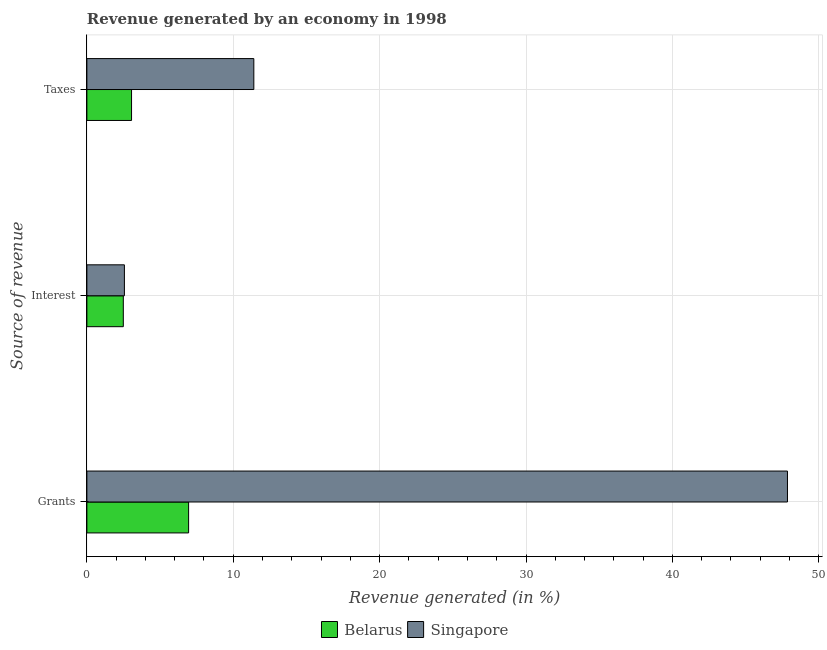How many groups of bars are there?
Keep it short and to the point. 3. Are the number of bars per tick equal to the number of legend labels?
Your answer should be very brief. Yes. How many bars are there on the 3rd tick from the bottom?
Your answer should be compact. 2. What is the label of the 1st group of bars from the top?
Offer a terse response. Taxes. What is the percentage of revenue generated by taxes in Singapore?
Your response must be concise. 11.41. Across all countries, what is the maximum percentage of revenue generated by interest?
Make the answer very short. 2.56. Across all countries, what is the minimum percentage of revenue generated by interest?
Give a very brief answer. 2.49. In which country was the percentage of revenue generated by taxes maximum?
Keep it short and to the point. Singapore. In which country was the percentage of revenue generated by interest minimum?
Your answer should be compact. Belarus. What is the total percentage of revenue generated by grants in the graph?
Provide a succinct answer. 54.81. What is the difference between the percentage of revenue generated by taxes in Belarus and that in Singapore?
Provide a succinct answer. -8.35. What is the difference between the percentage of revenue generated by interest in Singapore and the percentage of revenue generated by grants in Belarus?
Offer a very short reply. -4.39. What is the average percentage of revenue generated by grants per country?
Make the answer very short. 27.41. What is the difference between the percentage of revenue generated by taxes and percentage of revenue generated by grants in Belarus?
Offer a very short reply. -3.9. What is the ratio of the percentage of revenue generated by grants in Singapore to that in Belarus?
Ensure brevity in your answer.  6.89. Is the difference between the percentage of revenue generated by grants in Belarus and Singapore greater than the difference between the percentage of revenue generated by interest in Belarus and Singapore?
Provide a short and direct response. No. What is the difference between the highest and the second highest percentage of revenue generated by interest?
Offer a very short reply. 0.08. What is the difference between the highest and the lowest percentage of revenue generated by interest?
Keep it short and to the point. 0.08. In how many countries, is the percentage of revenue generated by interest greater than the average percentage of revenue generated by interest taken over all countries?
Provide a short and direct response. 1. Is the sum of the percentage of revenue generated by grants in Belarus and Singapore greater than the maximum percentage of revenue generated by interest across all countries?
Your answer should be very brief. Yes. What does the 1st bar from the top in Grants represents?
Keep it short and to the point. Singapore. What does the 1st bar from the bottom in Grants represents?
Offer a very short reply. Belarus. Is it the case that in every country, the sum of the percentage of revenue generated by grants and percentage of revenue generated by interest is greater than the percentage of revenue generated by taxes?
Offer a very short reply. Yes. What is the difference between two consecutive major ticks on the X-axis?
Give a very brief answer. 10. Are the values on the major ticks of X-axis written in scientific E-notation?
Your answer should be very brief. No. Does the graph contain grids?
Provide a short and direct response. Yes. Where does the legend appear in the graph?
Keep it short and to the point. Bottom center. What is the title of the graph?
Make the answer very short. Revenue generated by an economy in 1998. What is the label or title of the X-axis?
Offer a very short reply. Revenue generated (in %). What is the label or title of the Y-axis?
Your answer should be compact. Source of revenue. What is the Revenue generated (in %) of Belarus in Grants?
Your answer should be very brief. 6.95. What is the Revenue generated (in %) in Singapore in Grants?
Give a very brief answer. 47.86. What is the Revenue generated (in %) in Belarus in Interest?
Offer a very short reply. 2.49. What is the Revenue generated (in %) of Singapore in Interest?
Make the answer very short. 2.56. What is the Revenue generated (in %) in Belarus in Taxes?
Your response must be concise. 3.05. What is the Revenue generated (in %) of Singapore in Taxes?
Provide a short and direct response. 11.41. Across all Source of revenue, what is the maximum Revenue generated (in %) of Belarus?
Your answer should be compact. 6.95. Across all Source of revenue, what is the maximum Revenue generated (in %) in Singapore?
Your answer should be compact. 47.86. Across all Source of revenue, what is the minimum Revenue generated (in %) of Belarus?
Your answer should be very brief. 2.49. Across all Source of revenue, what is the minimum Revenue generated (in %) in Singapore?
Offer a terse response. 2.56. What is the total Revenue generated (in %) of Belarus in the graph?
Your response must be concise. 12.49. What is the total Revenue generated (in %) in Singapore in the graph?
Provide a short and direct response. 61.83. What is the difference between the Revenue generated (in %) of Belarus in Grants and that in Interest?
Offer a terse response. 4.46. What is the difference between the Revenue generated (in %) of Singapore in Grants and that in Interest?
Your answer should be compact. 45.3. What is the difference between the Revenue generated (in %) of Belarus in Grants and that in Taxes?
Your answer should be compact. 3.9. What is the difference between the Revenue generated (in %) in Singapore in Grants and that in Taxes?
Make the answer very short. 36.46. What is the difference between the Revenue generated (in %) of Belarus in Interest and that in Taxes?
Provide a short and direct response. -0.56. What is the difference between the Revenue generated (in %) of Singapore in Interest and that in Taxes?
Provide a succinct answer. -8.84. What is the difference between the Revenue generated (in %) of Belarus in Grants and the Revenue generated (in %) of Singapore in Interest?
Your answer should be compact. 4.39. What is the difference between the Revenue generated (in %) of Belarus in Grants and the Revenue generated (in %) of Singapore in Taxes?
Keep it short and to the point. -4.46. What is the difference between the Revenue generated (in %) of Belarus in Interest and the Revenue generated (in %) of Singapore in Taxes?
Offer a very short reply. -8.92. What is the average Revenue generated (in %) of Belarus per Source of revenue?
Keep it short and to the point. 4.16. What is the average Revenue generated (in %) of Singapore per Source of revenue?
Offer a terse response. 20.61. What is the difference between the Revenue generated (in %) of Belarus and Revenue generated (in %) of Singapore in Grants?
Give a very brief answer. -40.91. What is the difference between the Revenue generated (in %) in Belarus and Revenue generated (in %) in Singapore in Interest?
Provide a succinct answer. -0.07. What is the difference between the Revenue generated (in %) of Belarus and Revenue generated (in %) of Singapore in Taxes?
Your answer should be compact. -8.35. What is the ratio of the Revenue generated (in %) of Belarus in Grants to that in Interest?
Provide a succinct answer. 2.79. What is the ratio of the Revenue generated (in %) of Singapore in Grants to that in Interest?
Keep it short and to the point. 18.67. What is the ratio of the Revenue generated (in %) of Belarus in Grants to that in Taxes?
Keep it short and to the point. 2.28. What is the ratio of the Revenue generated (in %) in Singapore in Grants to that in Taxes?
Provide a short and direct response. 4.2. What is the ratio of the Revenue generated (in %) of Belarus in Interest to that in Taxes?
Your answer should be very brief. 0.82. What is the ratio of the Revenue generated (in %) of Singapore in Interest to that in Taxes?
Your answer should be compact. 0.22. What is the difference between the highest and the second highest Revenue generated (in %) in Belarus?
Provide a short and direct response. 3.9. What is the difference between the highest and the second highest Revenue generated (in %) in Singapore?
Your answer should be compact. 36.46. What is the difference between the highest and the lowest Revenue generated (in %) in Belarus?
Provide a succinct answer. 4.46. What is the difference between the highest and the lowest Revenue generated (in %) of Singapore?
Give a very brief answer. 45.3. 